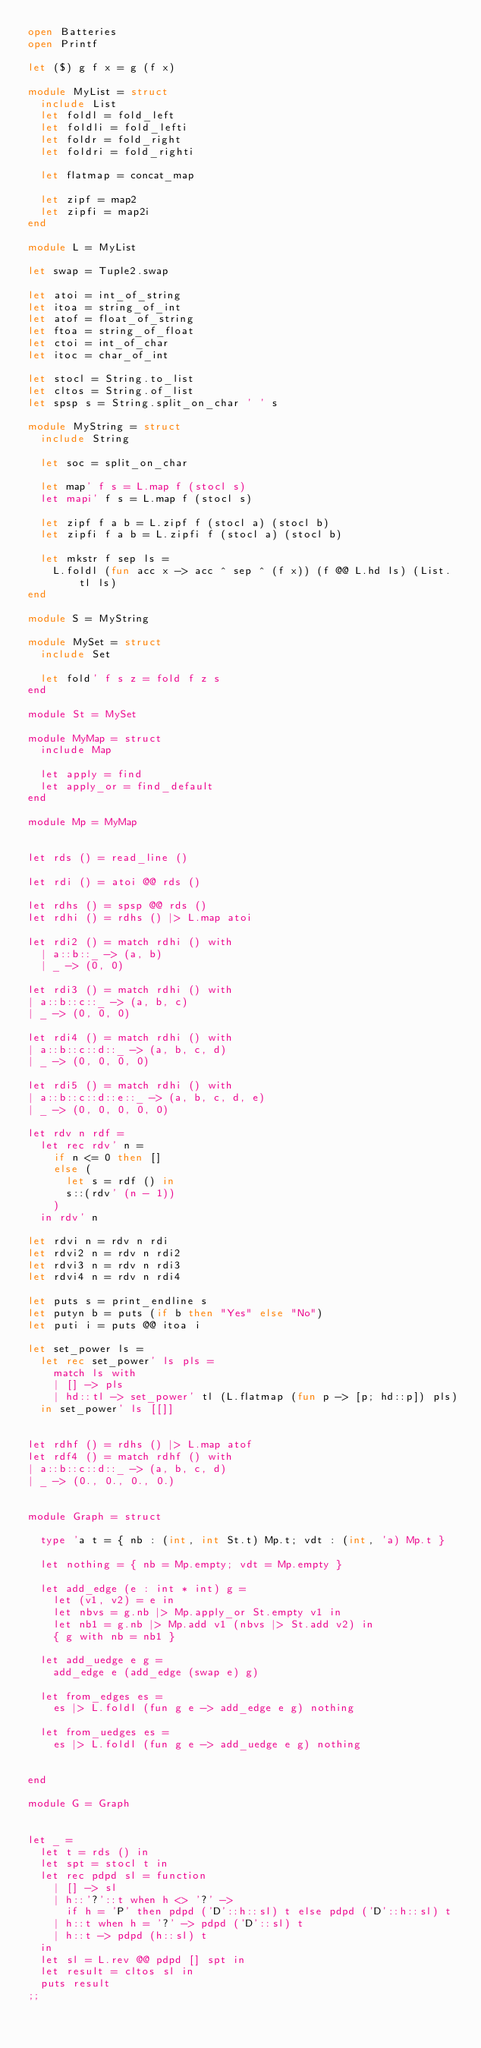Convert code to text. <code><loc_0><loc_0><loc_500><loc_500><_OCaml_>open Batteries
open Printf

let ($) g f x = g (f x)

module MyList = struct
  include List
  let foldl = fold_left
  let foldli = fold_lefti
  let foldr = fold_right
  let foldri = fold_righti
  
  let flatmap = concat_map

  let zipf = map2
  let zipfi = map2i
end

module L = MyList

let swap = Tuple2.swap

let atoi = int_of_string
let itoa = string_of_int
let atof = float_of_string
let ftoa = string_of_float
let ctoi = int_of_char
let itoc = char_of_int

let stocl = String.to_list
let cltos = String.of_list
let spsp s = String.split_on_char ' ' s

module MyString = struct
  include String

  let soc = split_on_char

  let map' f s = L.map f (stocl s)
  let mapi' f s = L.map f (stocl s)

  let zipf f a b = L.zipf f (stocl a) (stocl b)
  let zipfi f a b = L.zipfi f (stocl a) (stocl b)

  let mkstr f sep ls =
    L.foldl (fun acc x -> acc ^ sep ^ (f x)) (f @@ L.hd ls) (List.tl ls)
end

module S = MyString

module MySet = struct
  include Set

  let fold' f s z = fold f z s
end

module St = MySet

module MyMap = struct
  include Map

  let apply = find
  let apply_or = find_default
end

module Mp = MyMap


let rds () = read_line ()

let rdi () = atoi @@ rds ()

let rdhs () = spsp @@ rds ()
let rdhi () = rdhs () |> L.map atoi

let rdi2 () = match rdhi () with
  | a::b::_ -> (a, b)
  | _ -> (0, 0)

let rdi3 () = match rdhi () with
| a::b::c::_ -> (a, b, c)
| _ -> (0, 0, 0)

let rdi4 () = match rdhi () with
| a::b::c::d::_ -> (a, b, c, d)
| _ -> (0, 0, 0, 0)

let rdi5 () = match rdhi () with
| a::b::c::d::e::_ -> (a, b, c, d, e)
| _ -> (0, 0, 0, 0, 0)

let rdv n rdf =
  let rec rdv' n =
    if n <= 0 then []
    else (
      let s = rdf () in
      s::(rdv' (n - 1))
    )
  in rdv' n

let rdvi n = rdv n rdi
let rdvi2 n = rdv n rdi2
let rdvi3 n = rdv n rdi3
let rdvi4 n = rdv n rdi4

let puts s = print_endline s
let putyn b = puts (if b then "Yes" else "No")
let puti i = puts @@ itoa i

let set_power ls =
  let rec set_power' ls pls =
    match ls with
    | [] -> pls
    | hd::tl -> set_power' tl (L.flatmap (fun p -> [p; hd::p]) pls)
  in set_power' ls [[]]


let rdhf () = rdhs () |> L.map atof
let rdf4 () = match rdhf () with
| a::b::c::d::_ -> (a, b, c, d)
| _ -> (0., 0., 0., 0.)


module Graph = struct

  type 'a t = { nb : (int, int St.t) Mp.t; vdt : (int, 'a) Mp.t }

  let nothing = { nb = Mp.empty; vdt = Mp.empty }

  let add_edge (e : int * int) g =
    let (v1, v2) = e in
    let nbvs = g.nb |> Mp.apply_or St.empty v1 in
    let nb1 = g.nb |> Mp.add v1 (nbvs |> St.add v2) in
    { g with nb = nb1 }

  let add_uedge e g =
    add_edge e (add_edge (swap e) g)

  let from_edges es =
    es |> L.foldl (fun g e -> add_edge e g) nothing

  let from_uedges es =
    es |> L.foldl (fun g e -> add_uedge e g) nothing


end

module G = Graph


let _ =
  let t = rds () in
  let spt = stocl t in
  let rec pdpd sl = function
    | [] -> sl
    | h::'?'::t when h <> '?' -> 
      if h = 'P' then pdpd ('D'::h::sl) t else pdpd ('D'::h::sl) t
    | h::t when h = '?' -> pdpd ('D'::sl) t 
    | h::t -> pdpd (h::sl) t
  in
  let sl = L.rev @@ pdpd [] spt in
  let result = cltos sl in
  puts result
;;
</code> 